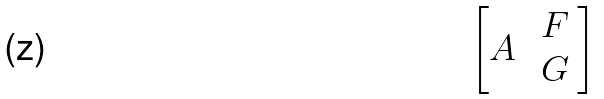<formula> <loc_0><loc_0><loc_500><loc_500>\begin{bmatrix} A & \begin{array} { c } F \\ G \end{array} \end{bmatrix}</formula> 